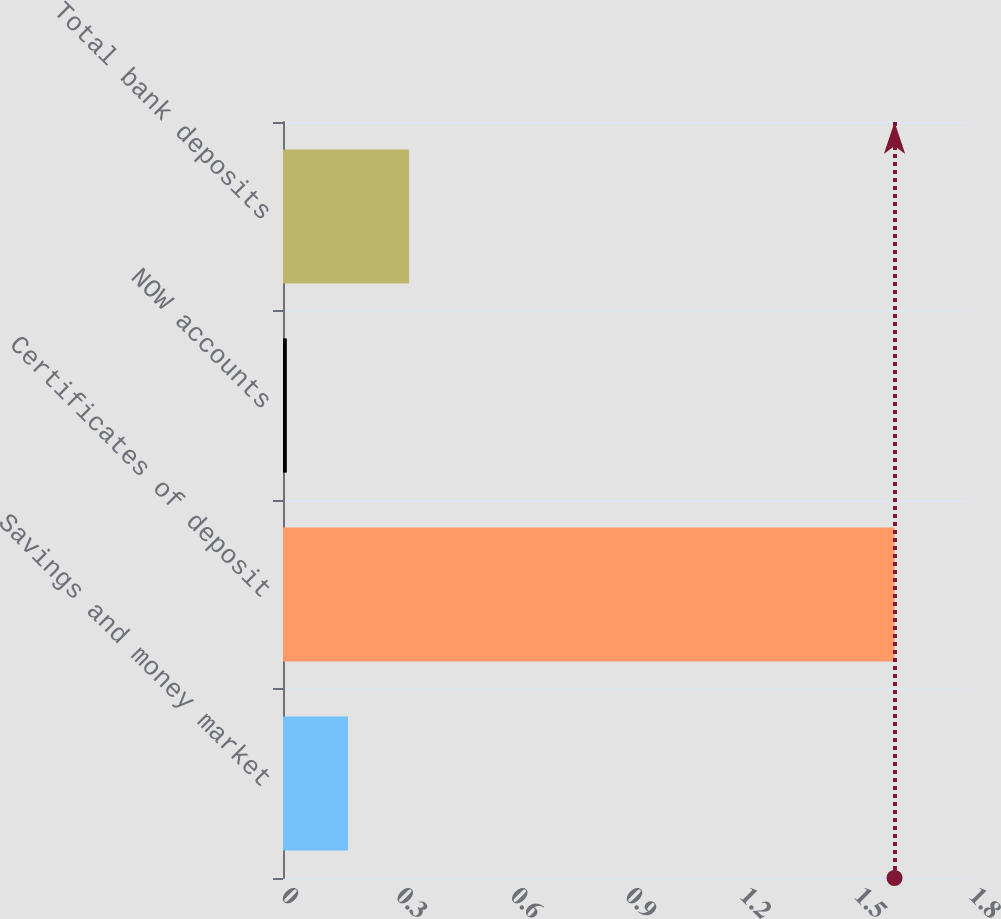<chart> <loc_0><loc_0><loc_500><loc_500><bar_chart><fcel>Savings and money market<fcel>Certificates of deposit<fcel>NOW accounts<fcel>Total bank deposits<nl><fcel>0.17<fcel>1.6<fcel>0.01<fcel>0.33<nl></chart> 